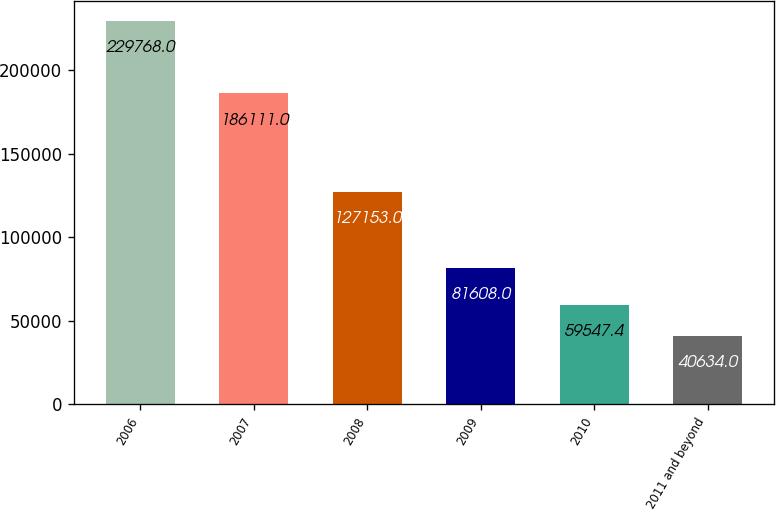Convert chart. <chart><loc_0><loc_0><loc_500><loc_500><bar_chart><fcel>2006<fcel>2007<fcel>2008<fcel>2009<fcel>2010<fcel>2011 and beyond<nl><fcel>229768<fcel>186111<fcel>127153<fcel>81608<fcel>59547.4<fcel>40634<nl></chart> 